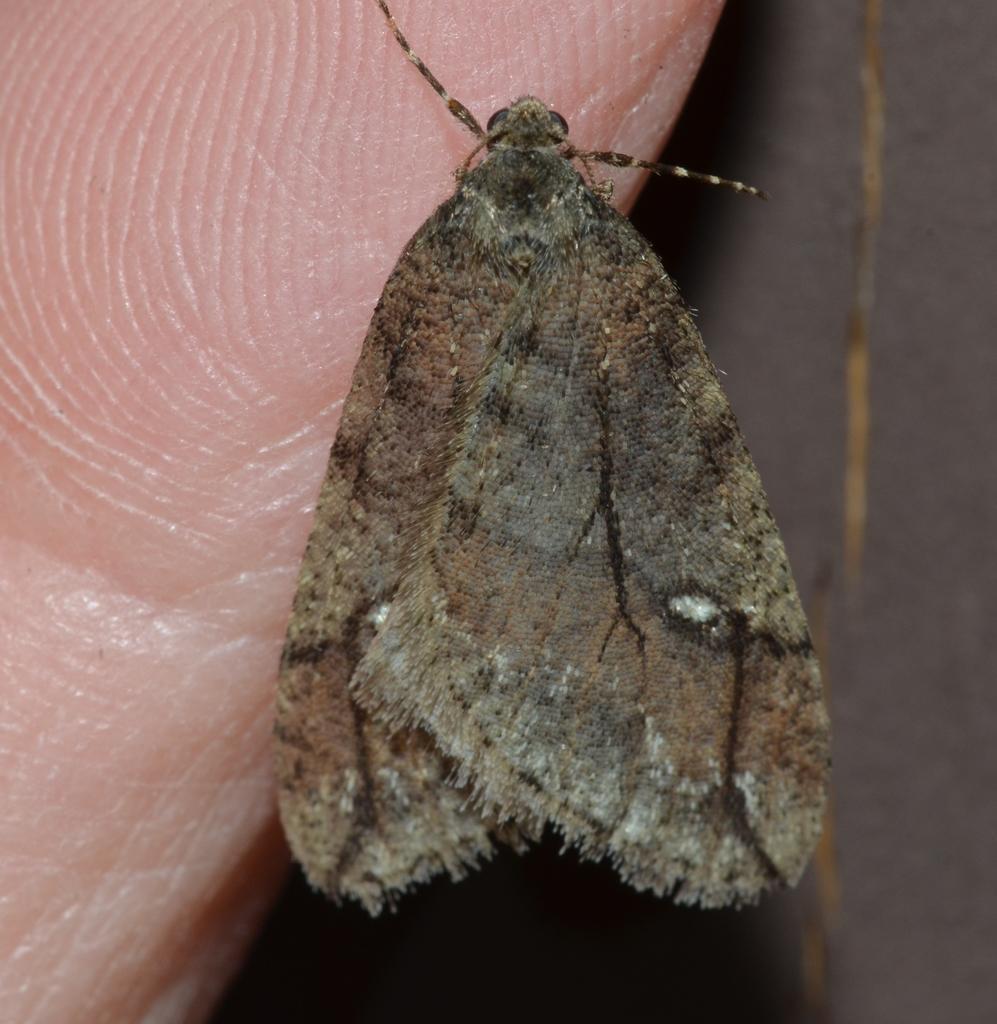How would you summarize this image in a sentence or two? As we can see in the image there is wall, an insect and human palm. 